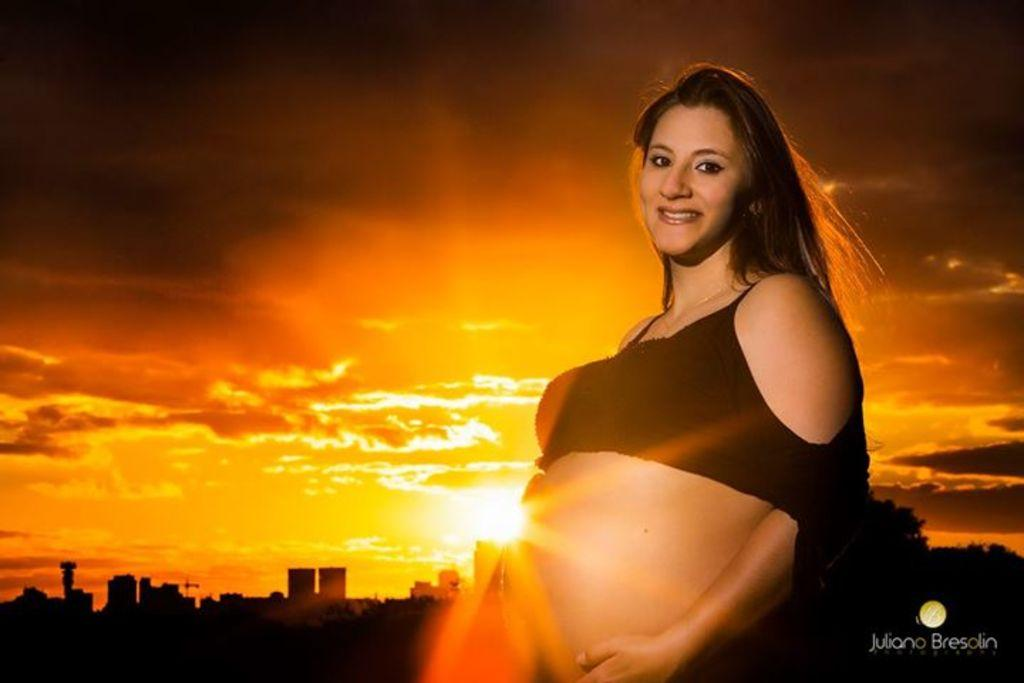Who is the main subject in the foreground of the image? There is a woman in the foreground of the image. What can be seen in the background of the image? There are buildings and the sun visible in the background of the image. What else is visible in the background of the image? The sky is also visible in the background of the image. What type of pet can be seen chained to the woman in the image? There is no pet present in the image, let alone one that is chained to the woman. 